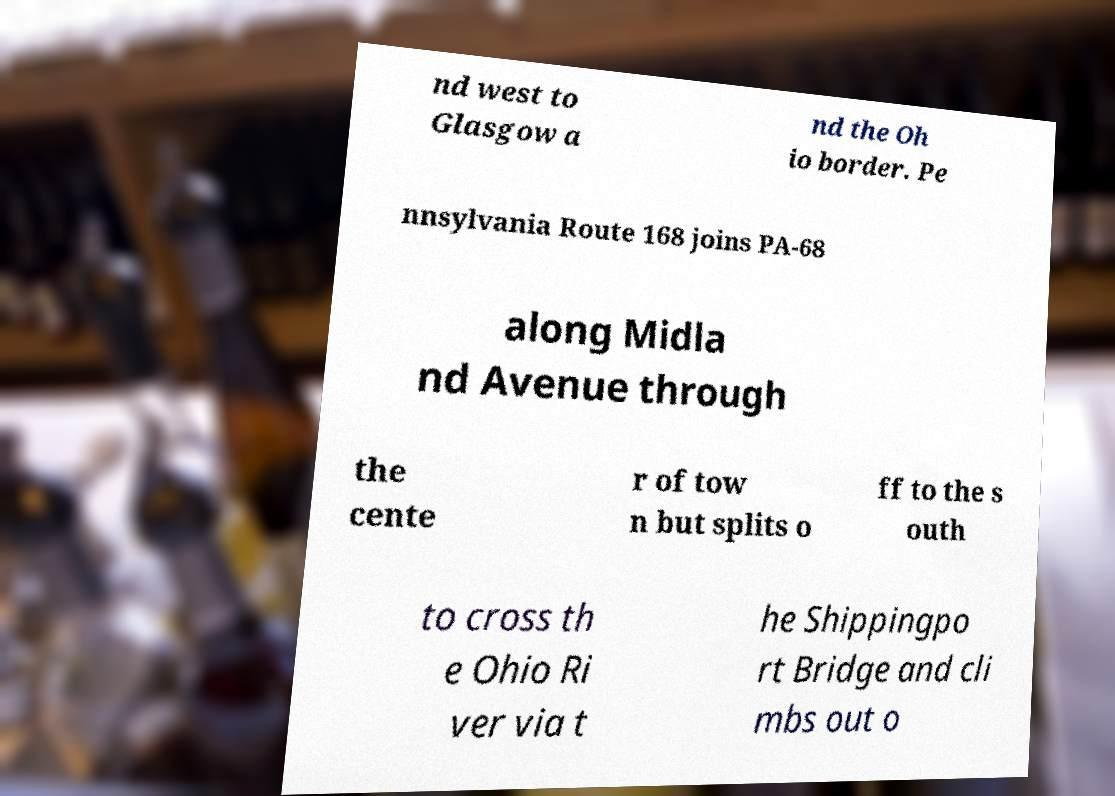I need the written content from this picture converted into text. Can you do that? nd west to Glasgow a nd the Oh io border. Pe nnsylvania Route 168 joins PA-68 along Midla nd Avenue through the cente r of tow n but splits o ff to the s outh to cross th e Ohio Ri ver via t he Shippingpo rt Bridge and cli mbs out o 